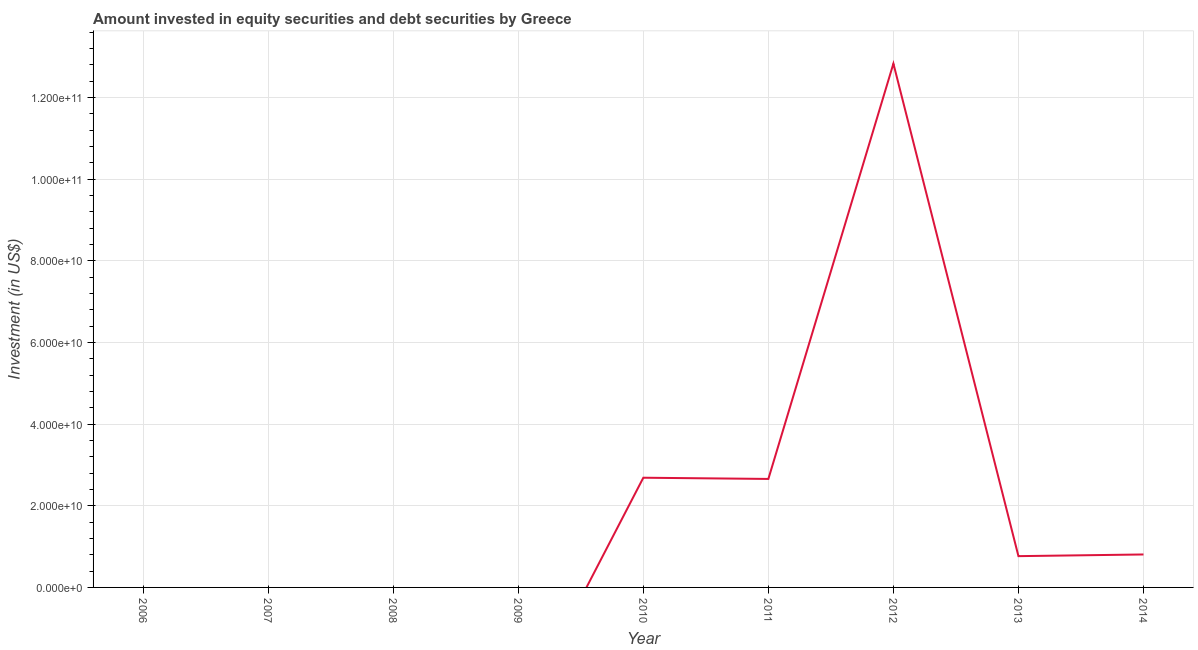What is the portfolio investment in 2013?
Give a very brief answer. 7.66e+09. Across all years, what is the maximum portfolio investment?
Provide a succinct answer. 1.28e+11. Across all years, what is the minimum portfolio investment?
Offer a very short reply. 0. What is the sum of the portfolio investment?
Ensure brevity in your answer.  1.97e+11. What is the difference between the portfolio investment in 2010 and 2014?
Your answer should be compact. 1.88e+1. What is the average portfolio investment per year?
Ensure brevity in your answer.  2.19e+1. What is the median portfolio investment?
Ensure brevity in your answer.  7.66e+09. In how many years, is the portfolio investment greater than 96000000000 US$?
Offer a very short reply. 1. What is the ratio of the portfolio investment in 2010 to that in 2011?
Offer a terse response. 1.01. Is the portfolio investment in 2011 less than that in 2012?
Provide a succinct answer. Yes. What is the difference between the highest and the second highest portfolio investment?
Keep it short and to the point. 1.01e+11. Is the sum of the portfolio investment in 2010 and 2013 greater than the maximum portfolio investment across all years?
Your response must be concise. No. What is the difference between the highest and the lowest portfolio investment?
Your answer should be very brief. 1.28e+11. How many years are there in the graph?
Offer a very short reply. 9. What is the difference between two consecutive major ticks on the Y-axis?
Your response must be concise. 2.00e+1. Does the graph contain any zero values?
Offer a very short reply. Yes. Does the graph contain grids?
Offer a terse response. Yes. What is the title of the graph?
Your answer should be very brief. Amount invested in equity securities and debt securities by Greece. What is the label or title of the Y-axis?
Your answer should be very brief. Investment (in US$). What is the Investment (in US$) of 2007?
Offer a very short reply. 0. What is the Investment (in US$) in 2008?
Offer a very short reply. 0. What is the Investment (in US$) of 2010?
Your answer should be compact. 2.69e+1. What is the Investment (in US$) in 2011?
Your answer should be compact. 2.66e+1. What is the Investment (in US$) in 2012?
Your answer should be compact. 1.28e+11. What is the Investment (in US$) of 2013?
Provide a succinct answer. 7.66e+09. What is the Investment (in US$) of 2014?
Keep it short and to the point. 8.07e+09. What is the difference between the Investment (in US$) in 2010 and 2011?
Your answer should be compact. 2.97e+08. What is the difference between the Investment (in US$) in 2010 and 2012?
Provide a succinct answer. -1.01e+11. What is the difference between the Investment (in US$) in 2010 and 2013?
Ensure brevity in your answer.  1.92e+1. What is the difference between the Investment (in US$) in 2010 and 2014?
Your response must be concise. 1.88e+1. What is the difference between the Investment (in US$) in 2011 and 2012?
Ensure brevity in your answer.  -1.02e+11. What is the difference between the Investment (in US$) in 2011 and 2013?
Make the answer very short. 1.89e+1. What is the difference between the Investment (in US$) in 2011 and 2014?
Provide a short and direct response. 1.85e+1. What is the difference between the Investment (in US$) in 2012 and 2013?
Keep it short and to the point. 1.21e+11. What is the difference between the Investment (in US$) in 2012 and 2014?
Give a very brief answer. 1.20e+11. What is the difference between the Investment (in US$) in 2013 and 2014?
Give a very brief answer. -4.12e+08. What is the ratio of the Investment (in US$) in 2010 to that in 2011?
Your answer should be compact. 1.01. What is the ratio of the Investment (in US$) in 2010 to that in 2012?
Give a very brief answer. 0.21. What is the ratio of the Investment (in US$) in 2010 to that in 2013?
Keep it short and to the point. 3.51. What is the ratio of the Investment (in US$) in 2010 to that in 2014?
Your answer should be very brief. 3.33. What is the ratio of the Investment (in US$) in 2011 to that in 2012?
Give a very brief answer. 0.21. What is the ratio of the Investment (in US$) in 2011 to that in 2013?
Provide a succinct answer. 3.47. What is the ratio of the Investment (in US$) in 2011 to that in 2014?
Your answer should be very brief. 3.29. What is the ratio of the Investment (in US$) in 2012 to that in 2013?
Provide a succinct answer. 16.75. What is the ratio of the Investment (in US$) in 2012 to that in 2014?
Offer a very short reply. 15.89. What is the ratio of the Investment (in US$) in 2013 to that in 2014?
Provide a short and direct response. 0.95. 